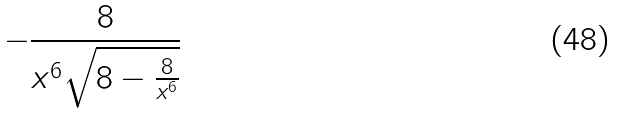Convert formula to latex. <formula><loc_0><loc_0><loc_500><loc_500>- \frac { 8 } { x ^ { 6 } \sqrt { 8 - \frac { 8 } { x ^ { 6 } } } }</formula> 